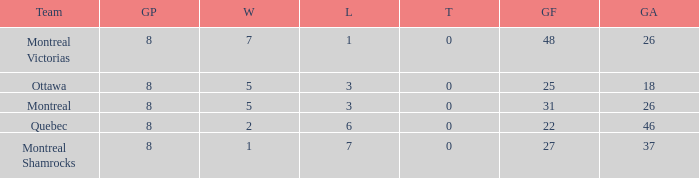For teams with more than 0 ties and goals against of 37, how many wins were tallied? None. 